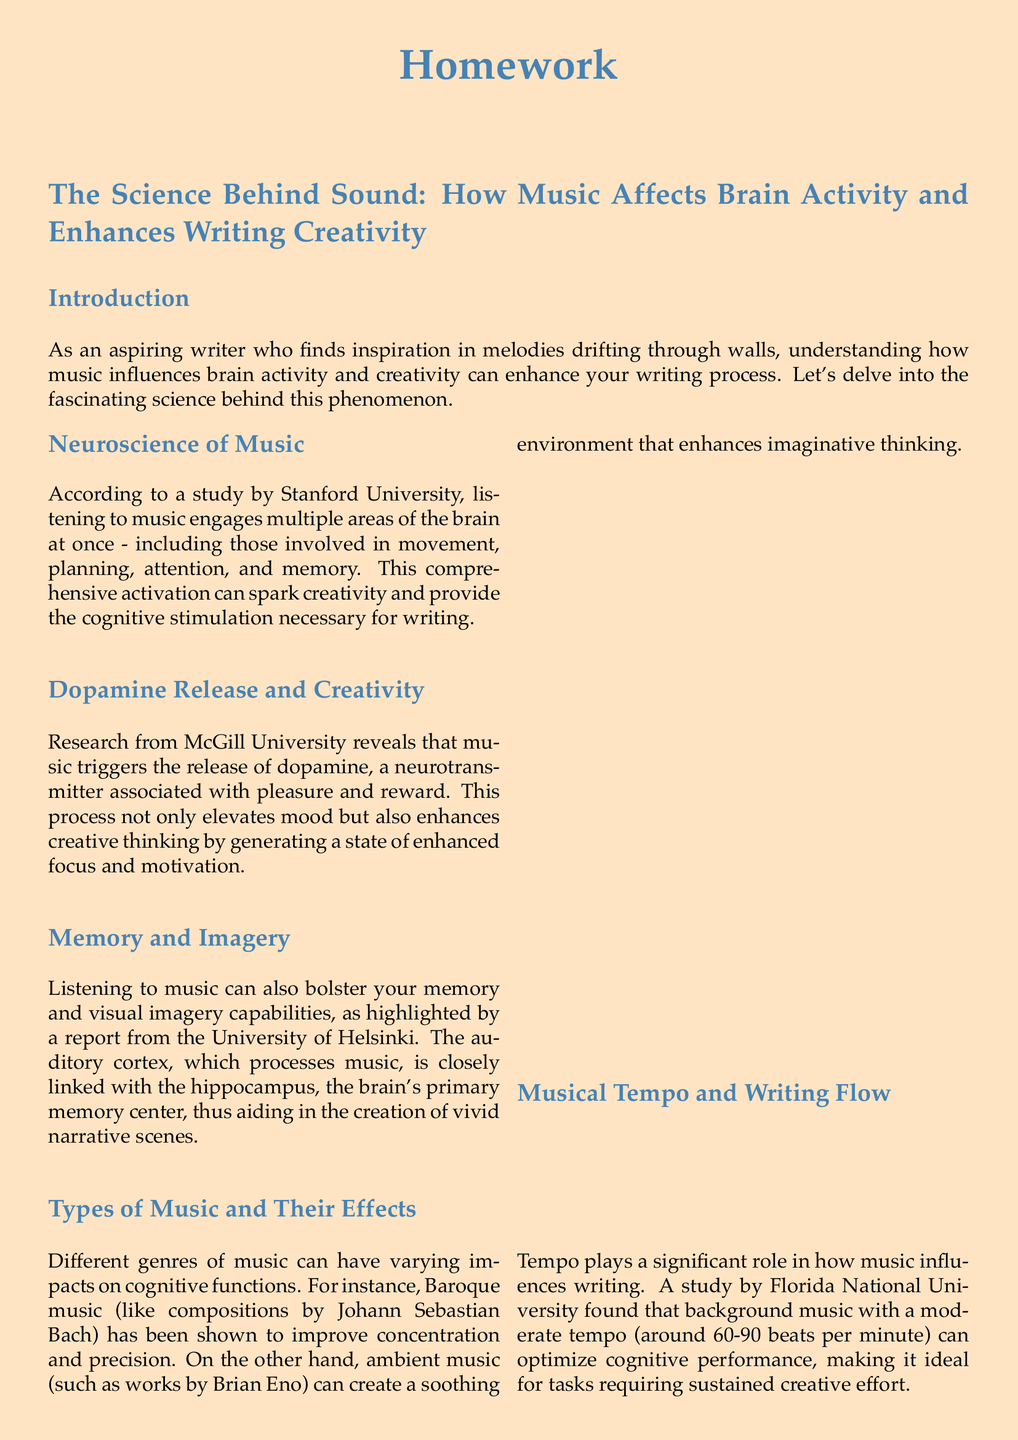What university conducted a study on the neuroscience of music? The document mentions Stanford University as the institution that conducted the neuroscience of music study.
Answer: Stanford University What neurotransmitter is associated with pleasure and reward in music? The document states that dopamine is the neurotransmitter linked to pleasure and reward when music is played.
Answer: Dopamine Which genre of music is noted for improving concentration and precision? The document identifies Baroque music, specifically compositions by Johann Sebastian Bach, as enhancing concentration and precision.
Answer: Baroque music What is the optimal tempo for background music according to the study by Florida National University? The document indicates that a moderate tempo, around 60-90 beats per minute, is considered ideal for cognitive performance.
Answer: 60-90 beats per minute What effect does music have on memory and visual imagery capabilities? The document highlights that music bolsters memory and visual imagery by linking the auditory cortex with the hippocampus.
Answer: Bolsters memory and visual imagery How does listening to music affect creative thinking? The document explains that music enhances creative thinking by triggering dopamine release, which elevates mood and focus.
Answer: Enhances creative thinking What report discusses the connection between music, memory, and imagery? The document references a report from the University of Helsinki that deals with music, memory, and imagery.
Answer: University of Helsinki What is the purpose of the document? The document is designed as a homework assignment to explore how music affects brain activity and writing creativity.
Answer: Homework assignment 